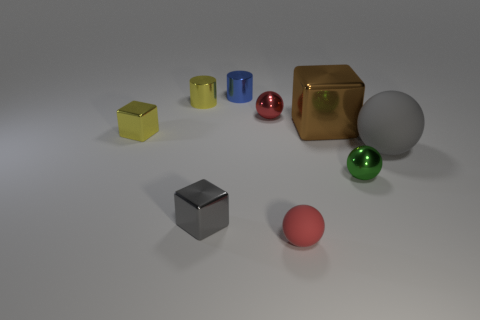Subtract all cyan blocks. How many red balls are left? 2 Subtract all gray spheres. How many spheres are left? 3 Subtract all big rubber balls. How many balls are left? 3 Subtract all balls. How many objects are left? 5 Add 1 large brown metal cubes. How many objects exist? 10 Subtract all brown spheres. Subtract all brown cylinders. How many spheres are left? 4 Subtract 1 brown cubes. How many objects are left? 8 Subtract all shiny balls. Subtract all small yellow metal blocks. How many objects are left? 6 Add 5 blue shiny cylinders. How many blue shiny cylinders are left? 6 Add 5 small yellow rubber objects. How many small yellow rubber objects exist? 5 